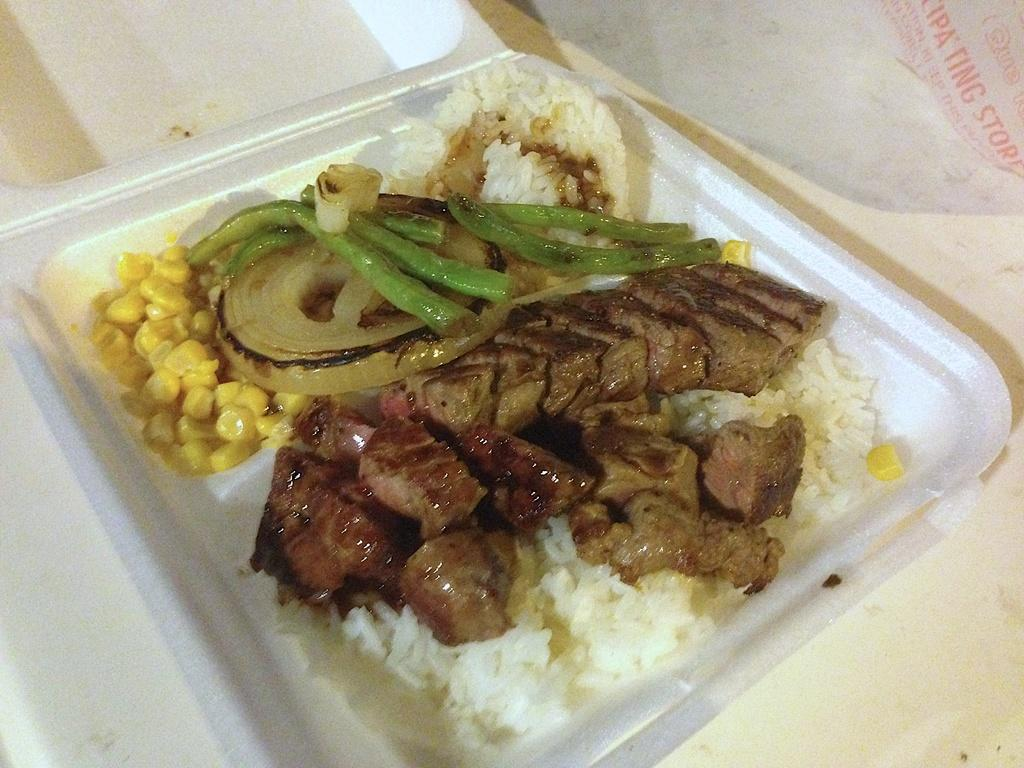What can be seen in the image? There are food items in the image. How are the food items arranged or presented? The food items are in a plate. What type of prison is depicted in the image? There is no prison present in the image; it features food items in a plate. How does the judge interact with the food items in the image? There is no judge present in the image; it features food items in a plate. 